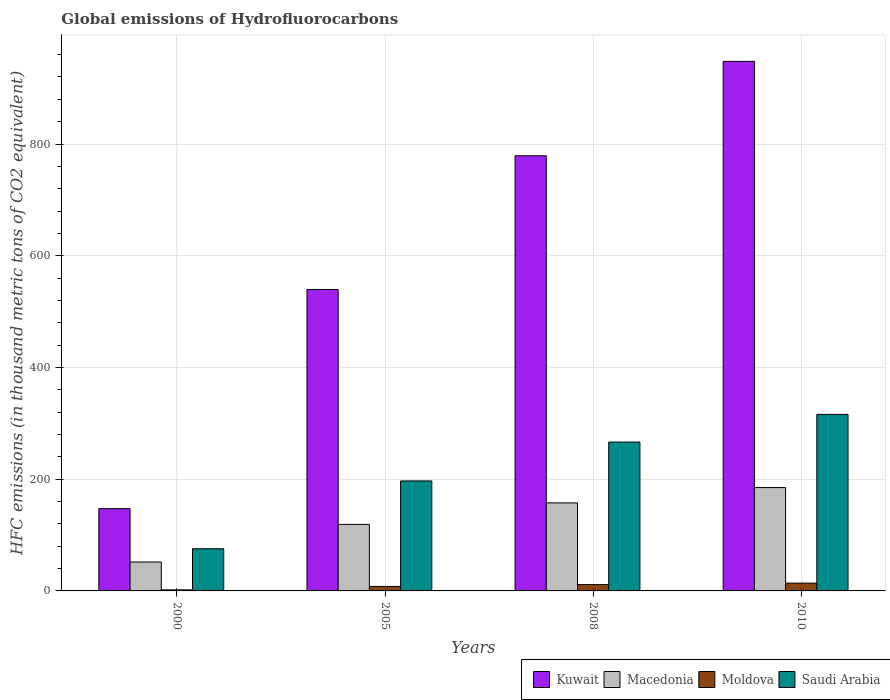Are the number of bars per tick equal to the number of legend labels?
Offer a terse response. Yes. Are the number of bars on each tick of the X-axis equal?
Keep it short and to the point. Yes. How many bars are there on the 3rd tick from the right?
Keep it short and to the point. 4. What is the label of the 3rd group of bars from the left?
Your answer should be compact. 2008. What is the global emissions of Hydrofluorocarbons in Saudi Arabia in 2008?
Offer a very short reply. 266.5. Across all years, what is the maximum global emissions of Hydrofluorocarbons in Macedonia?
Your answer should be compact. 185. In which year was the global emissions of Hydrofluorocarbons in Macedonia minimum?
Provide a succinct answer. 2000. What is the total global emissions of Hydrofluorocarbons in Kuwait in the graph?
Provide a succinct answer. 2413.9. What is the difference between the global emissions of Hydrofluorocarbons in Macedonia in 2005 and that in 2008?
Offer a very short reply. -38.5. What is the difference between the global emissions of Hydrofluorocarbons in Saudi Arabia in 2010 and the global emissions of Hydrofluorocarbons in Macedonia in 2005?
Your answer should be compact. 196.9. In the year 2010, what is the difference between the global emissions of Hydrofluorocarbons in Macedonia and global emissions of Hydrofluorocarbons in Kuwait?
Provide a succinct answer. -763. In how many years, is the global emissions of Hydrofluorocarbons in Saudi Arabia greater than 120 thousand metric tons?
Offer a very short reply. 3. What is the ratio of the global emissions of Hydrofluorocarbons in Moldova in 2000 to that in 2010?
Offer a terse response. 0.14. What is the difference between the highest and the second highest global emissions of Hydrofluorocarbons in Kuwait?
Your answer should be very brief. 169. In how many years, is the global emissions of Hydrofluorocarbons in Kuwait greater than the average global emissions of Hydrofluorocarbons in Kuwait taken over all years?
Make the answer very short. 2. Is the sum of the global emissions of Hydrofluorocarbons in Saudi Arabia in 2008 and 2010 greater than the maximum global emissions of Hydrofluorocarbons in Macedonia across all years?
Give a very brief answer. Yes. What does the 2nd bar from the left in 2010 represents?
Offer a terse response. Macedonia. What does the 3rd bar from the right in 2005 represents?
Your answer should be very brief. Macedonia. How many years are there in the graph?
Keep it short and to the point. 4. What is the difference between two consecutive major ticks on the Y-axis?
Your answer should be compact. 200. Are the values on the major ticks of Y-axis written in scientific E-notation?
Give a very brief answer. No. Does the graph contain any zero values?
Provide a succinct answer. No. Does the graph contain grids?
Make the answer very short. Yes. How many legend labels are there?
Ensure brevity in your answer.  4. What is the title of the graph?
Ensure brevity in your answer.  Global emissions of Hydrofluorocarbons. Does "Montenegro" appear as one of the legend labels in the graph?
Your answer should be very brief. No. What is the label or title of the Y-axis?
Your answer should be compact. HFC emissions (in thousand metric tons of CO2 equivalent). What is the HFC emissions (in thousand metric tons of CO2 equivalent) of Kuwait in 2000?
Offer a very short reply. 147.3. What is the HFC emissions (in thousand metric tons of CO2 equivalent) of Macedonia in 2000?
Offer a terse response. 51.8. What is the HFC emissions (in thousand metric tons of CO2 equivalent) of Saudi Arabia in 2000?
Ensure brevity in your answer.  75.5. What is the HFC emissions (in thousand metric tons of CO2 equivalent) in Kuwait in 2005?
Provide a succinct answer. 539.6. What is the HFC emissions (in thousand metric tons of CO2 equivalent) in Macedonia in 2005?
Offer a terse response. 119.1. What is the HFC emissions (in thousand metric tons of CO2 equivalent) in Moldova in 2005?
Your answer should be compact. 8. What is the HFC emissions (in thousand metric tons of CO2 equivalent) in Saudi Arabia in 2005?
Give a very brief answer. 196.9. What is the HFC emissions (in thousand metric tons of CO2 equivalent) in Kuwait in 2008?
Offer a very short reply. 779. What is the HFC emissions (in thousand metric tons of CO2 equivalent) of Macedonia in 2008?
Ensure brevity in your answer.  157.6. What is the HFC emissions (in thousand metric tons of CO2 equivalent) in Saudi Arabia in 2008?
Your response must be concise. 266.5. What is the HFC emissions (in thousand metric tons of CO2 equivalent) of Kuwait in 2010?
Provide a short and direct response. 948. What is the HFC emissions (in thousand metric tons of CO2 equivalent) of Macedonia in 2010?
Your response must be concise. 185. What is the HFC emissions (in thousand metric tons of CO2 equivalent) in Moldova in 2010?
Your answer should be compact. 14. What is the HFC emissions (in thousand metric tons of CO2 equivalent) of Saudi Arabia in 2010?
Make the answer very short. 316. Across all years, what is the maximum HFC emissions (in thousand metric tons of CO2 equivalent) in Kuwait?
Provide a short and direct response. 948. Across all years, what is the maximum HFC emissions (in thousand metric tons of CO2 equivalent) in Macedonia?
Your response must be concise. 185. Across all years, what is the maximum HFC emissions (in thousand metric tons of CO2 equivalent) of Saudi Arabia?
Your response must be concise. 316. Across all years, what is the minimum HFC emissions (in thousand metric tons of CO2 equivalent) of Kuwait?
Ensure brevity in your answer.  147.3. Across all years, what is the minimum HFC emissions (in thousand metric tons of CO2 equivalent) in Macedonia?
Offer a terse response. 51.8. Across all years, what is the minimum HFC emissions (in thousand metric tons of CO2 equivalent) in Saudi Arabia?
Make the answer very short. 75.5. What is the total HFC emissions (in thousand metric tons of CO2 equivalent) in Kuwait in the graph?
Your answer should be compact. 2413.9. What is the total HFC emissions (in thousand metric tons of CO2 equivalent) of Macedonia in the graph?
Keep it short and to the point. 513.5. What is the total HFC emissions (in thousand metric tons of CO2 equivalent) of Moldova in the graph?
Ensure brevity in your answer.  35.2. What is the total HFC emissions (in thousand metric tons of CO2 equivalent) in Saudi Arabia in the graph?
Ensure brevity in your answer.  854.9. What is the difference between the HFC emissions (in thousand metric tons of CO2 equivalent) in Kuwait in 2000 and that in 2005?
Keep it short and to the point. -392.3. What is the difference between the HFC emissions (in thousand metric tons of CO2 equivalent) of Macedonia in 2000 and that in 2005?
Give a very brief answer. -67.3. What is the difference between the HFC emissions (in thousand metric tons of CO2 equivalent) in Saudi Arabia in 2000 and that in 2005?
Provide a succinct answer. -121.4. What is the difference between the HFC emissions (in thousand metric tons of CO2 equivalent) in Kuwait in 2000 and that in 2008?
Keep it short and to the point. -631.7. What is the difference between the HFC emissions (in thousand metric tons of CO2 equivalent) of Macedonia in 2000 and that in 2008?
Your response must be concise. -105.8. What is the difference between the HFC emissions (in thousand metric tons of CO2 equivalent) of Saudi Arabia in 2000 and that in 2008?
Offer a very short reply. -191. What is the difference between the HFC emissions (in thousand metric tons of CO2 equivalent) in Kuwait in 2000 and that in 2010?
Your answer should be very brief. -800.7. What is the difference between the HFC emissions (in thousand metric tons of CO2 equivalent) of Macedonia in 2000 and that in 2010?
Keep it short and to the point. -133.2. What is the difference between the HFC emissions (in thousand metric tons of CO2 equivalent) in Moldova in 2000 and that in 2010?
Ensure brevity in your answer.  -12.1. What is the difference between the HFC emissions (in thousand metric tons of CO2 equivalent) in Saudi Arabia in 2000 and that in 2010?
Provide a short and direct response. -240.5. What is the difference between the HFC emissions (in thousand metric tons of CO2 equivalent) of Kuwait in 2005 and that in 2008?
Give a very brief answer. -239.4. What is the difference between the HFC emissions (in thousand metric tons of CO2 equivalent) of Macedonia in 2005 and that in 2008?
Give a very brief answer. -38.5. What is the difference between the HFC emissions (in thousand metric tons of CO2 equivalent) of Saudi Arabia in 2005 and that in 2008?
Your response must be concise. -69.6. What is the difference between the HFC emissions (in thousand metric tons of CO2 equivalent) in Kuwait in 2005 and that in 2010?
Your answer should be compact. -408.4. What is the difference between the HFC emissions (in thousand metric tons of CO2 equivalent) in Macedonia in 2005 and that in 2010?
Offer a very short reply. -65.9. What is the difference between the HFC emissions (in thousand metric tons of CO2 equivalent) in Saudi Arabia in 2005 and that in 2010?
Offer a very short reply. -119.1. What is the difference between the HFC emissions (in thousand metric tons of CO2 equivalent) in Kuwait in 2008 and that in 2010?
Provide a succinct answer. -169. What is the difference between the HFC emissions (in thousand metric tons of CO2 equivalent) in Macedonia in 2008 and that in 2010?
Make the answer very short. -27.4. What is the difference between the HFC emissions (in thousand metric tons of CO2 equivalent) in Saudi Arabia in 2008 and that in 2010?
Give a very brief answer. -49.5. What is the difference between the HFC emissions (in thousand metric tons of CO2 equivalent) in Kuwait in 2000 and the HFC emissions (in thousand metric tons of CO2 equivalent) in Macedonia in 2005?
Provide a short and direct response. 28.2. What is the difference between the HFC emissions (in thousand metric tons of CO2 equivalent) of Kuwait in 2000 and the HFC emissions (in thousand metric tons of CO2 equivalent) of Moldova in 2005?
Your answer should be compact. 139.3. What is the difference between the HFC emissions (in thousand metric tons of CO2 equivalent) of Kuwait in 2000 and the HFC emissions (in thousand metric tons of CO2 equivalent) of Saudi Arabia in 2005?
Your response must be concise. -49.6. What is the difference between the HFC emissions (in thousand metric tons of CO2 equivalent) of Macedonia in 2000 and the HFC emissions (in thousand metric tons of CO2 equivalent) of Moldova in 2005?
Your answer should be compact. 43.8. What is the difference between the HFC emissions (in thousand metric tons of CO2 equivalent) in Macedonia in 2000 and the HFC emissions (in thousand metric tons of CO2 equivalent) in Saudi Arabia in 2005?
Provide a succinct answer. -145.1. What is the difference between the HFC emissions (in thousand metric tons of CO2 equivalent) of Moldova in 2000 and the HFC emissions (in thousand metric tons of CO2 equivalent) of Saudi Arabia in 2005?
Make the answer very short. -195. What is the difference between the HFC emissions (in thousand metric tons of CO2 equivalent) of Kuwait in 2000 and the HFC emissions (in thousand metric tons of CO2 equivalent) of Moldova in 2008?
Keep it short and to the point. 136. What is the difference between the HFC emissions (in thousand metric tons of CO2 equivalent) in Kuwait in 2000 and the HFC emissions (in thousand metric tons of CO2 equivalent) in Saudi Arabia in 2008?
Provide a short and direct response. -119.2. What is the difference between the HFC emissions (in thousand metric tons of CO2 equivalent) in Macedonia in 2000 and the HFC emissions (in thousand metric tons of CO2 equivalent) in Moldova in 2008?
Keep it short and to the point. 40.5. What is the difference between the HFC emissions (in thousand metric tons of CO2 equivalent) of Macedonia in 2000 and the HFC emissions (in thousand metric tons of CO2 equivalent) of Saudi Arabia in 2008?
Offer a very short reply. -214.7. What is the difference between the HFC emissions (in thousand metric tons of CO2 equivalent) in Moldova in 2000 and the HFC emissions (in thousand metric tons of CO2 equivalent) in Saudi Arabia in 2008?
Provide a succinct answer. -264.6. What is the difference between the HFC emissions (in thousand metric tons of CO2 equivalent) of Kuwait in 2000 and the HFC emissions (in thousand metric tons of CO2 equivalent) of Macedonia in 2010?
Provide a short and direct response. -37.7. What is the difference between the HFC emissions (in thousand metric tons of CO2 equivalent) of Kuwait in 2000 and the HFC emissions (in thousand metric tons of CO2 equivalent) of Moldova in 2010?
Offer a terse response. 133.3. What is the difference between the HFC emissions (in thousand metric tons of CO2 equivalent) of Kuwait in 2000 and the HFC emissions (in thousand metric tons of CO2 equivalent) of Saudi Arabia in 2010?
Keep it short and to the point. -168.7. What is the difference between the HFC emissions (in thousand metric tons of CO2 equivalent) of Macedonia in 2000 and the HFC emissions (in thousand metric tons of CO2 equivalent) of Moldova in 2010?
Your response must be concise. 37.8. What is the difference between the HFC emissions (in thousand metric tons of CO2 equivalent) in Macedonia in 2000 and the HFC emissions (in thousand metric tons of CO2 equivalent) in Saudi Arabia in 2010?
Provide a short and direct response. -264.2. What is the difference between the HFC emissions (in thousand metric tons of CO2 equivalent) of Moldova in 2000 and the HFC emissions (in thousand metric tons of CO2 equivalent) of Saudi Arabia in 2010?
Give a very brief answer. -314.1. What is the difference between the HFC emissions (in thousand metric tons of CO2 equivalent) of Kuwait in 2005 and the HFC emissions (in thousand metric tons of CO2 equivalent) of Macedonia in 2008?
Your answer should be compact. 382. What is the difference between the HFC emissions (in thousand metric tons of CO2 equivalent) in Kuwait in 2005 and the HFC emissions (in thousand metric tons of CO2 equivalent) in Moldova in 2008?
Make the answer very short. 528.3. What is the difference between the HFC emissions (in thousand metric tons of CO2 equivalent) in Kuwait in 2005 and the HFC emissions (in thousand metric tons of CO2 equivalent) in Saudi Arabia in 2008?
Your answer should be very brief. 273.1. What is the difference between the HFC emissions (in thousand metric tons of CO2 equivalent) of Macedonia in 2005 and the HFC emissions (in thousand metric tons of CO2 equivalent) of Moldova in 2008?
Offer a terse response. 107.8. What is the difference between the HFC emissions (in thousand metric tons of CO2 equivalent) in Macedonia in 2005 and the HFC emissions (in thousand metric tons of CO2 equivalent) in Saudi Arabia in 2008?
Keep it short and to the point. -147.4. What is the difference between the HFC emissions (in thousand metric tons of CO2 equivalent) of Moldova in 2005 and the HFC emissions (in thousand metric tons of CO2 equivalent) of Saudi Arabia in 2008?
Provide a short and direct response. -258.5. What is the difference between the HFC emissions (in thousand metric tons of CO2 equivalent) of Kuwait in 2005 and the HFC emissions (in thousand metric tons of CO2 equivalent) of Macedonia in 2010?
Give a very brief answer. 354.6. What is the difference between the HFC emissions (in thousand metric tons of CO2 equivalent) of Kuwait in 2005 and the HFC emissions (in thousand metric tons of CO2 equivalent) of Moldova in 2010?
Offer a very short reply. 525.6. What is the difference between the HFC emissions (in thousand metric tons of CO2 equivalent) of Kuwait in 2005 and the HFC emissions (in thousand metric tons of CO2 equivalent) of Saudi Arabia in 2010?
Keep it short and to the point. 223.6. What is the difference between the HFC emissions (in thousand metric tons of CO2 equivalent) in Macedonia in 2005 and the HFC emissions (in thousand metric tons of CO2 equivalent) in Moldova in 2010?
Give a very brief answer. 105.1. What is the difference between the HFC emissions (in thousand metric tons of CO2 equivalent) in Macedonia in 2005 and the HFC emissions (in thousand metric tons of CO2 equivalent) in Saudi Arabia in 2010?
Keep it short and to the point. -196.9. What is the difference between the HFC emissions (in thousand metric tons of CO2 equivalent) of Moldova in 2005 and the HFC emissions (in thousand metric tons of CO2 equivalent) of Saudi Arabia in 2010?
Offer a very short reply. -308. What is the difference between the HFC emissions (in thousand metric tons of CO2 equivalent) of Kuwait in 2008 and the HFC emissions (in thousand metric tons of CO2 equivalent) of Macedonia in 2010?
Provide a succinct answer. 594. What is the difference between the HFC emissions (in thousand metric tons of CO2 equivalent) in Kuwait in 2008 and the HFC emissions (in thousand metric tons of CO2 equivalent) in Moldova in 2010?
Your response must be concise. 765. What is the difference between the HFC emissions (in thousand metric tons of CO2 equivalent) of Kuwait in 2008 and the HFC emissions (in thousand metric tons of CO2 equivalent) of Saudi Arabia in 2010?
Your answer should be very brief. 463. What is the difference between the HFC emissions (in thousand metric tons of CO2 equivalent) in Macedonia in 2008 and the HFC emissions (in thousand metric tons of CO2 equivalent) in Moldova in 2010?
Provide a succinct answer. 143.6. What is the difference between the HFC emissions (in thousand metric tons of CO2 equivalent) in Macedonia in 2008 and the HFC emissions (in thousand metric tons of CO2 equivalent) in Saudi Arabia in 2010?
Your answer should be very brief. -158.4. What is the difference between the HFC emissions (in thousand metric tons of CO2 equivalent) of Moldova in 2008 and the HFC emissions (in thousand metric tons of CO2 equivalent) of Saudi Arabia in 2010?
Offer a terse response. -304.7. What is the average HFC emissions (in thousand metric tons of CO2 equivalent) in Kuwait per year?
Your answer should be very brief. 603.48. What is the average HFC emissions (in thousand metric tons of CO2 equivalent) in Macedonia per year?
Give a very brief answer. 128.38. What is the average HFC emissions (in thousand metric tons of CO2 equivalent) in Moldova per year?
Give a very brief answer. 8.8. What is the average HFC emissions (in thousand metric tons of CO2 equivalent) in Saudi Arabia per year?
Your answer should be compact. 213.72. In the year 2000, what is the difference between the HFC emissions (in thousand metric tons of CO2 equivalent) in Kuwait and HFC emissions (in thousand metric tons of CO2 equivalent) in Macedonia?
Provide a succinct answer. 95.5. In the year 2000, what is the difference between the HFC emissions (in thousand metric tons of CO2 equivalent) of Kuwait and HFC emissions (in thousand metric tons of CO2 equivalent) of Moldova?
Your answer should be very brief. 145.4. In the year 2000, what is the difference between the HFC emissions (in thousand metric tons of CO2 equivalent) of Kuwait and HFC emissions (in thousand metric tons of CO2 equivalent) of Saudi Arabia?
Ensure brevity in your answer.  71.8. In the year 2000, what is the difference between the HFC emissions (in thousand metric tons of CO2 equivalent) of Macedonia and HFC emissions (in thousand metric tons of CO2 equivalent) of Moldova?
Give a very brief answer. 49.9. In the year 2000, what is the difference between the HFC emissions (in thousand metric tons of CO2 equivalent) in Macedonia and HFC emissions (in thousand metric tons of CO2 equivalent) in Saudi Arabia?
Your answer should be very brief. -23.7. In the year 2000, what is the difference between the HFC emissions (in thousand metric tons of CO2 equivalent) of Moldova and HFC emissions (in thousand metric tons of CO2 equivalent) of Saudi Arabia?
Give a very brief answer. -73.6. In the year 2005, what is the difference between the HFC emissions (in thousand metric tons of CO2 equivalent) of Kuwait and HFC emissions (in thousand metric tons of CO2 equivalent) of Macedonia?
Provide a succinct answer. 420.5. In the year 2005, what is the difference between the HFC emissions (in thousand metric tons of CO2 equivalent) in Kuwait and HFC emissions (in thousand metric tons of CO2 equivalent) in Moldova?
Offer a very short reply. 531.6. In the year 2005, what is the difference between the HFC emissions (in thousand metric tons of CO2 equivalent) of Kuwait and HFC emissions (in thousand metric tons of CO2 equivalent) of Saudi Arabia?
Ensure brevity in your answer.  342.7. In the year 2005, what is the difference between the HFC emissions (in thousand metric tons of CO2 equivalent) of Macedonia and HFC emissions (in thousand metric tons of CO2 equivalent) of Moldova?
Offer a terse response. 111.1. In the year 2005, what is the difference between the HFC emissions (in thousand metric tons of CO2 equivalent) in Macedonia and HFC emissions (in thousand metric tons of CO2 equivalent) in Saudi Arabia?
Make the answer very short. -77.8. In the year 2005, what is the difference between the HFC emissions (in thousand metric tons of CO2 equivalent) of Moldova and HFC emissions (in thousand metric tons of CO2 equivalent) of Saudi Arabia?
Offer a terse response. -188.9. In the year 2008, what is the difference between the HFC emissions (in thousand metric tons of CO2 equivalent) in Kuwait and HFC emissions (in thousand metric tons of CO2 equivalent) in Macedonia?
Offer a terse response. 621.4. In the year 2008, what is the difference between the HFC emissions (in thousand metric tons of CO2 equivalent) in Kuwait and HFC emissions (in thousand metric tons of CO2 equivalent) in Moldova?
Give a very brief answer. 767.7. In the year 2008, what is the difference between the HFC emissions (in thousand metric tons of CO2 equivalent) in Kuwait and HFC emissions (in thousand metric tons of CO2 equivalent) in Saudi Arabia?
Keep it short and to the point. 512.5. In the year 2008, what is the difference between the HFC emissions (in thousand metric tons of CO2 equivalent) of Macedonia and HFC emissions (in thousand metric tons of CO2 equivalent) of Moldova?
Your answer should be compact. 146.3. In the year 2008, what is the difference between the HFC emissions (in thousand metric tons of CO2 equivalent) of Macedonia and HFC emissions (in thousand metric tons of CO2 equivalent) of Saudi Arabia?
Provide a succinct answer. -108.9. In the year 2008, what is the difference between the HFC emissions (in thousand metric tons of CO2 equivalent) in Moldova and HFC emissions (in thousand metric tons of CO2 equivalent) in Saudi Arabia?
Offer a very short reply. -255.2. In the year 2010, what is the difference between the HFC emissions (in thousand metric tons of CO2 equivalent) of Kuwait and HFC emissions (in thousand metric tons of CO2 equivalent) of Macedonia?
Give a very brief answer. 763. In the year 2010, what is the difference between the HFC emissions (in thousand metric tons of CO2 equivalent) in Kuwait and HFC emissions (in thousand metric tons of CO2 equivalent) in Moldova?
Offer a terse response. 934. In the year 2010, what is the difference between the HFC emissions (in thousand metric tons of CO2 equivalent) in Kuwait and HFC emissions (in thousand metric tons of CO2 equivalent) in Saudi Arabia?
Ensure brevity in your answer.  632. In the year 2010, what is the difference between the HFC emissions (in thousand metric tons of CO2 equivalent) of Macedonia and HFC emissions (in thousand metric tons of CO2 equivalent) of Moldova?
Offer a very short reply. 171. In the year 2010, what is the difference between the HFC emissions (in thousand metric tons of CO2 equivalent) of Macedonia and HFC emissions (in thousand metric tons of CO2 equivalent) of Saudi Arabia?
Give a very brief answer. -131. In the year 2010, what is the difference between the HFC emissions (in thousand metric tons of CO2 equivalent) in Moldova and HFC emissions (in thousand metric tons of CO2 equivalent) in Saudi Arabia?
Make the answer very short. -302. What is the ratio of the HFC emissions (in thousand metric tons of CO2 equivalent) in Kuwait in 2000 to that in 2005?
Give a very brief answer. 0.27. What is the ratio of the HFC emissions (in thousand metric tons of CO2 equivalent) of Macedonia in 2000 to that in 2005?
Provide a succinct answer. 0.43. What is the ratio of the HFC emissions (in thousand metric tons of CO2 equivalent) of Moldova in 2000 to that in 2005?
Your response must be concise. 0.24. What is the ratio of the HFC emissions (in thousand metric tons of CO2 equivalent) in Saudi Arabia in 2000 to that in 2005?
Your answer should be very brief. 0.38. What is the ratio of the HFC emissions (in thousand metric tons of CO2 equivalent) of Kuwait in 2000 to that in 2008?
Give a very brief answer. 0.19. What is the ratio of the HFC emissions (in thousand metric tons of CO2 equivalent) in Macedonia in 2000 to that in 2008?
Provide a short and direct response. 0.33. What is the ratio of the HFC emissions (in thousand metric tons of CO2 equivalent) in Moldova in 2000 to that in 2008?
Make the answer very short. 0.17. What is the ratio of the HFC emissions (in thousand metric tons of CO2 equivalent) in Saudi Arabia in 2000 to that in 2008?
Provide a succinct answer. 0.28. What is the ratio of the HFC emissions (in thousand metric tons of CO2 equivalent) in Kuwait in 2000 to that in 2010?
Keep it short and to the point. 0.16. What is the ratio of the HFC emissions (in thousand metric tons of CO2 equivalent) of Macedonia in 2000 to that in 2010?
Ensure brevity in your answer.  0.28. What is the ratio of the HFC emissions (in thousand metric tons of CO2 equivalent) of Moldova in 2000 to that in 2010?
Ensure brevity in your answer.  0.14. What is the ratio of the HFC emissions (in thousand metric tons of CO2 equivalent) in Saudi Arabia in 2000 to that in 2010?
Your response must be concise. 0.24. What is the ratio of the HFC emissions (in thousand metric tons of CO2 equivalent) of Kuwait in 2005 to that in 2008?
Ensure brevity in your answer.  0.69. What is the ratio of the HFC emissions (in thousand metric tons of CO2 equivalent) in Macedonia in 2005 to that in 2008?
Keep it short and to the point. 0.76. What is the ratio of the HFC emissions (in thousand metric tons of CO2 equivalent) in Moldova in 2005 to that in 2008?
Make the answer very short. 0.71. What is the ratio of the HFC emissions (in thousand metric tons of CO2 equivalent) of Saudi Arabia in 2005 to that in 2008?
Keep it short and to the point. 0.74. What is the ratio of the HFC emissions (in thousand metric tons of CO2 equivalent) in Kuwait in 2005 to that in 2010?
Provide a short and direct response. 0.57. What is the ratio of the HFC emissions (in thousand metric tons of CO2 equivalent) of Macedonia in 2005 to that in 2010?
Your answer should be compact. 0.64. What is the ratio of the HFC emissions (in thousand metric tons of CO2 equivalent) of Moldova in 2005 to that in 2010?
Your answer should be very brief. 0.57. What is the ratio of the HFC emissions (in thousand metric tons of CO2 equivalent) in Saudi Arabia in 2005 to that in 2010?
Offer a very short reply. 0.62. What is the ratio of the HFC emissions (in thousand metric tons of CO2 equivalent) of Kuwait in 2008 to that in 2010?
Your response must be concise. 0.82. What is the ratio of the HFC emissions (in thousand metric tons of CO2 equivalent) of Macedonia in 2008 to that in 2010?
Give a very brief answer. 0.85. What is the ratio of the HFC emissions (in thousand metric tons of CO2 equivalent) in Moldova in 2008 to that in 2010?
Offer a very short reply. 0.81. What is the ratio of the HFC emissions (in thousand metric tons of CO2 equivalent) of Saudi Arabia in 2008 to that in 2010?
Your answer should be very brief. 0.84. What is the difference between the highest and the second highest HFC emissions (in thousand metric tons of CO2 equivalent) in Kuwait?
Make the answer very short. 169. What is the difference between the highest and the second highest HFC emissions (in thousand metric tons of CO2 equivalent) of Macedonia?
Offer a very short reply. 27.4. What is the difference between the highest and the second highest HFC emissions (in thousand metric tons of CO2 equivalent) of Moldova?
Your response must be concise. 2.7. What is the difference between the highest and the second highest HFC emissions (in thousand metric tons of CO2 equivalent) in Saudi Arabia?
Make the answer very short. 49.5. What is the difference between the highest and the lowest HFC emissions (in thousand metric tons of CO2 equivalent) in Kuwait?
Offer a terse response. 800.7. What is the difference between the highest and the lowest HFC emissions (in thousand metric tons of CO2 equivalent) of Macedonia?
Your answer should be very brief. 133.2. What is the difference between the highest and the lowest HFC emissions (in thousand metric tons of CO2 equivalent) of Moldova?
Your answer should be compact. 12.1. What is the difference between the highest and the lowest HFC emissions (in thousand metric tons of CO2 equivalent) of Saudi Arabia?
Offer a terse response. 240.5. 